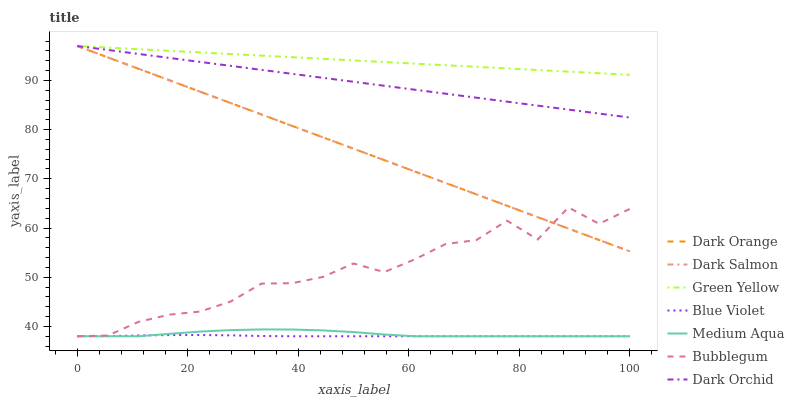Does Blue Violet have the minimum area under the curve?
Answer yes or no. Yes. Does Green Yellow have the maximum area under the curve?
Answer yes or no. Yes. Does Dark Salmon have the minimum area under the curve?
Answer yes or no. No. Does Dark Salmon have the maximum area under the curve?
Answer yes or no. No. Is Green Yellow the smoothest?
Answer yes or no. Yes. Is Bubblegum the roughest?
Answer yes or no. Yes. Is Dark Salmon the smoothest?
Answer yes or no. No. Is Dark Salmon the roughest?
Answer yes or no. No. Does Bubblegum have the lowest value?
Answer yes or no. Yes. Does Dark Salmon have the lowest value?
Answer yes or no. No. Does Green Yellow have the highest value?
Answer yes or no. Yes. Does Bubblegum have the highest value?
Answer yes or no. No. Is Bubblegum less than Green Yellow?
Answer yes or no. Yes. Is Dark Orange greater than Medium Aqua?
Answer yes or no. Yes. Does Dark Orange intersect Dark Salmon?
Answer yes or no. Yes. Is Dark Orange less than Dark Salmon?
Answer yes or no. No. Is Dark Orange greater than Dark Salmon?
Answer yes or no. No. Does Bubblegum intersect Green Yellow?
Answer yes or no. No. 